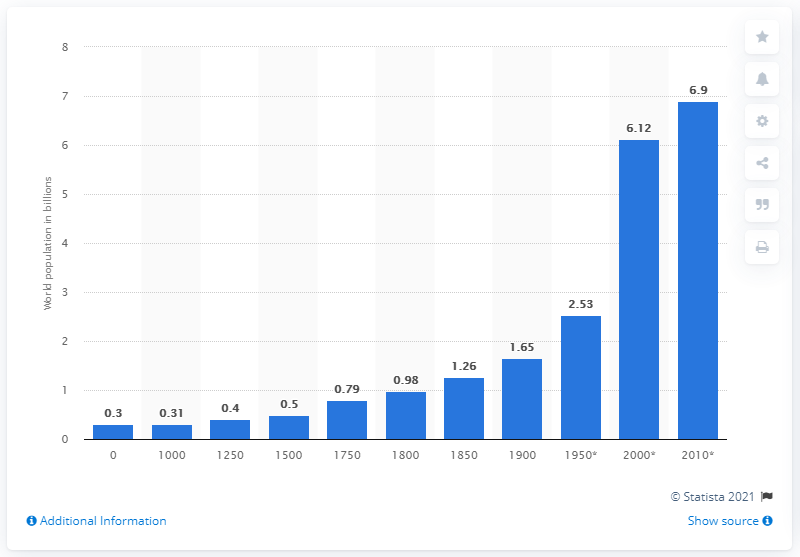Give some essential details in this illustration. In 2010, it is estimated that approximately 6.9 billion people were living on Earth. 